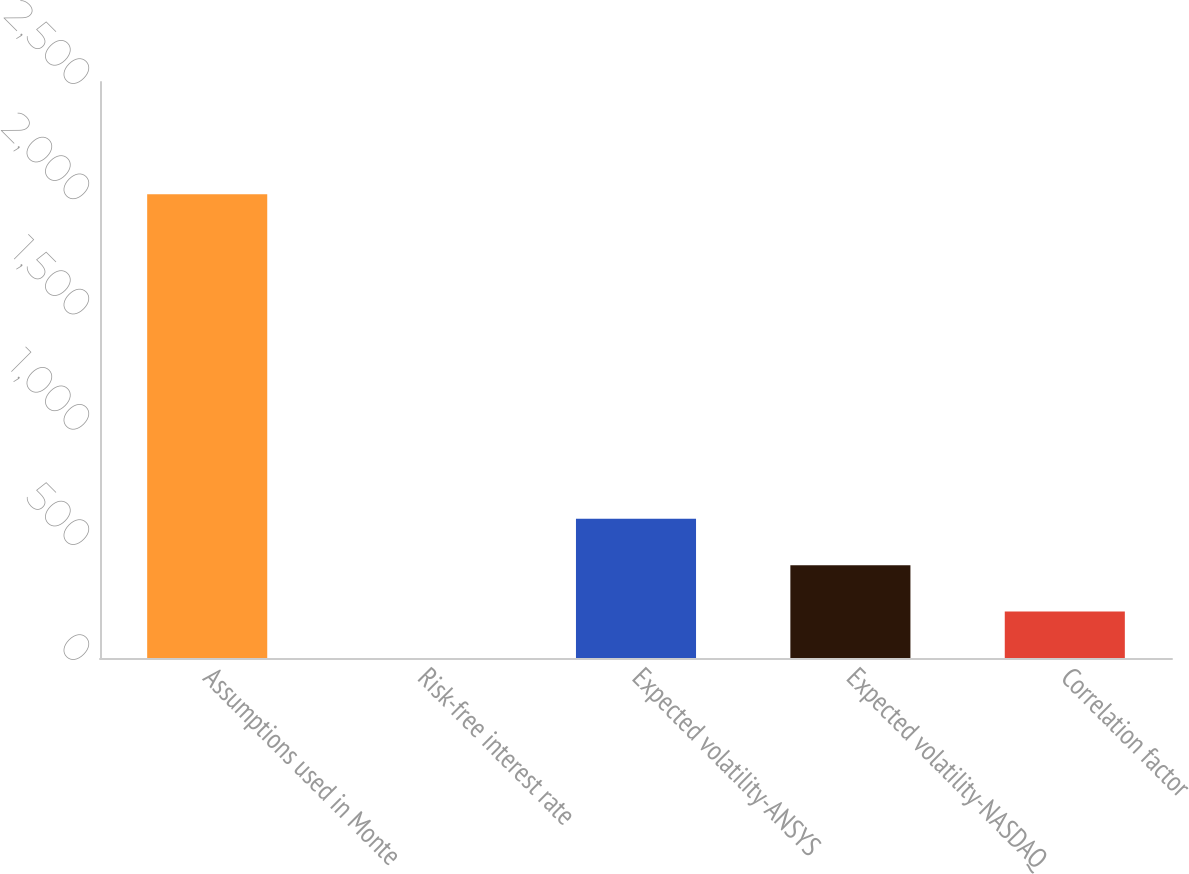Convert chart. <chart><loc_0><loc_0><loc_500><loc_500><bar_chart><fcel>Assumptions used in Monte<fcel>Risk-free interest rate<fcel>Expected volatility-ANSYS<fcel>Expected volatility-NASDAQ<fcel>Correlation factor<nl><fcel>2013<fcel>0.35<fcel>604.14<fcel>402.88<fcel>201.62<nl></chart> 